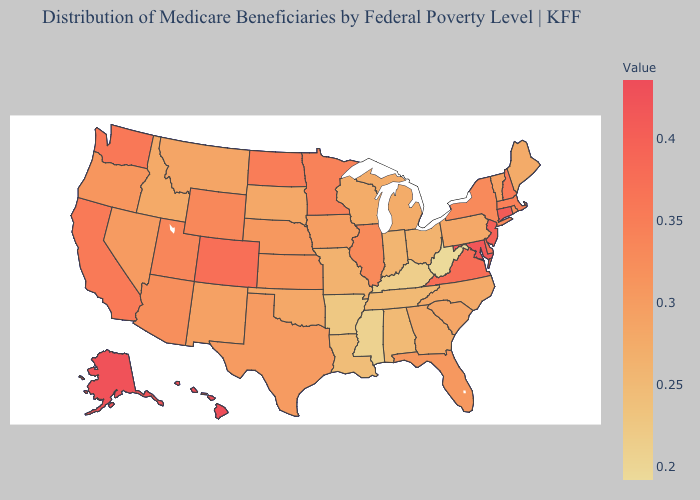Does Montana have the highest value in the USA?
Answer briefly. No. Which states have the highest value in the USA?
Give a very brief answer. Hawaii. Does Oklahoma have a lower value than Arkansas?
Answer briefly. No. Among the states that border South Carolina , which have the lowest value?
Keep it brief. Georgia, North Carolina. Among the states that border Massachusetts , which have the highest value?
Keep it brief. Connecticut. Among the states that border Indiana , does Illinois have the highest value?
Be succinct. Yes. 